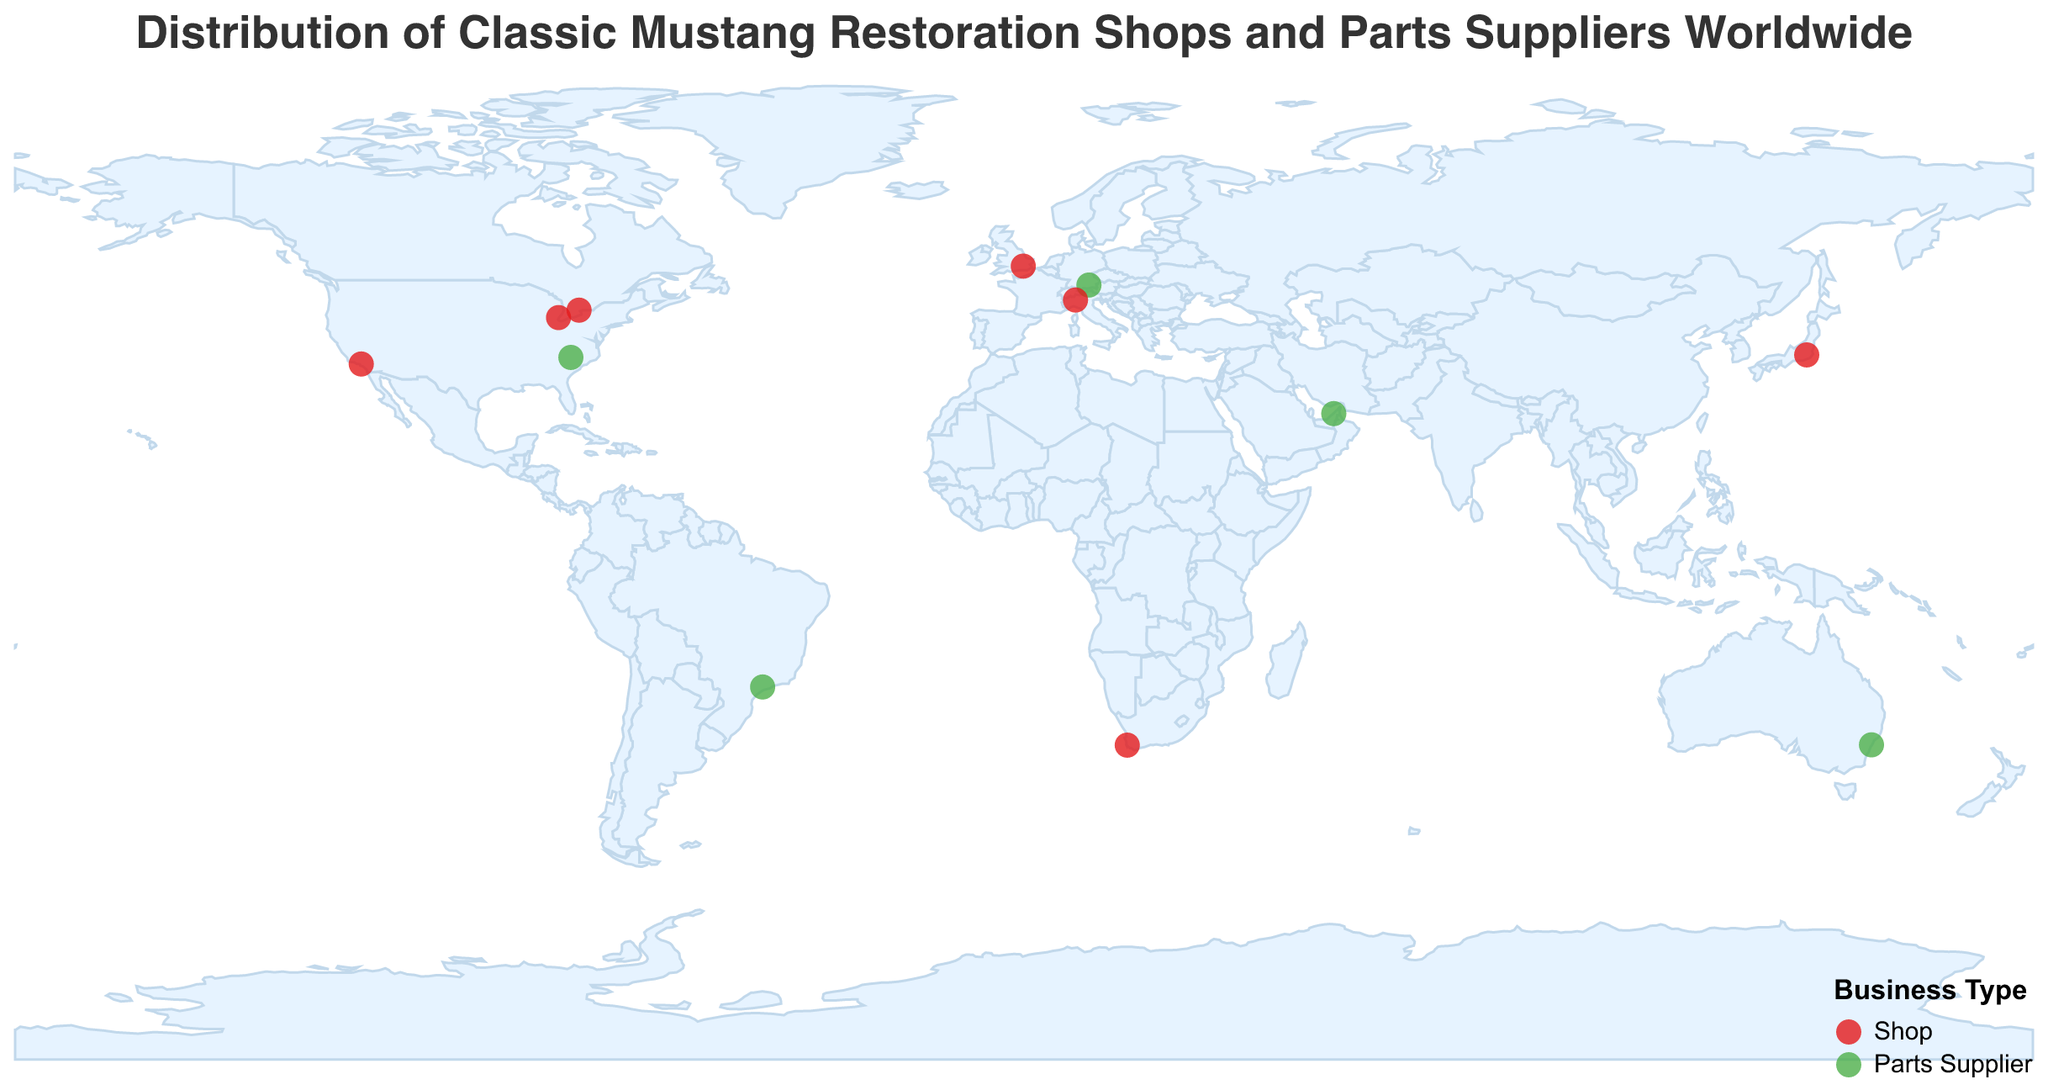What is the title of the figure? The title of the figure is usually situated at the top of the plot, providing a summary of what the plot is about.
Answer: Distribution of Classic Mustang Restoration Shops and Parts Suppliers Worldwide How many restoration shops are displayed on the map? Count the circles representing restoration shops color-coded in red on the map.
Answer: 7 Which city in Germany is marked on the plot? Identify the city in Germany by looking for the circle corresponding to Germany's coordinates.
Answer: Munich Which country has the most entries of Mustang restoration shops and parts suppliers combined? Count the number of circles for each country and identify the one with the highest count.
Answer: USA Are there any restoration shops located in Asia? If so, which city? Look for red-coded circles within the Asian continent's boundaries.
Answer: Yes, Tokyo Which continent has the fewest number of entries? Compare the number of circles across different continents and identify the one with the least count.
Answer: Africa What are the two types of businesses represented on the map? Check the color legend that denotes the type of businesses shown on the map.
Answer: Shop and Parts Supplier How many countries in total are represented on the map? Count the number of unique countries marked with circles on the map.
Answer: 12 Is there a parts supplier in South America? If so, which city? Look for green-coded circles within South America's boundaries.
Answer: Yes, Sao Paulo Which city in Australia houses a parts supplier? Identify the city in Australia by looking for the circle corresponding to Australia's coordinates.
Answer: Sydney 